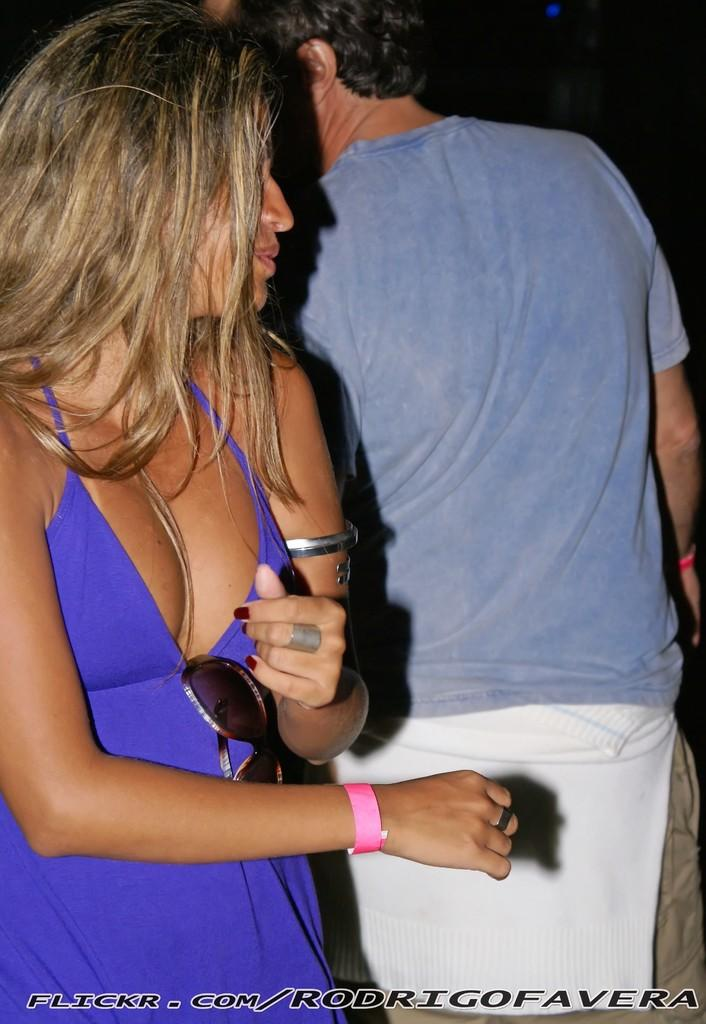What are the two people in the image doing? The man and woman in the image are standing. Can you describe the appearance of the two people? There is a man and a woman in the image, but their specific features are not mentioned in the facts. What is the color or lighting of the background in the image? The background of the image is dark. What type of pie is being baked in the image? There is no pie or any indication of baking in the image. Is there a volcano visible in the image? There is no volcano present in the image. 